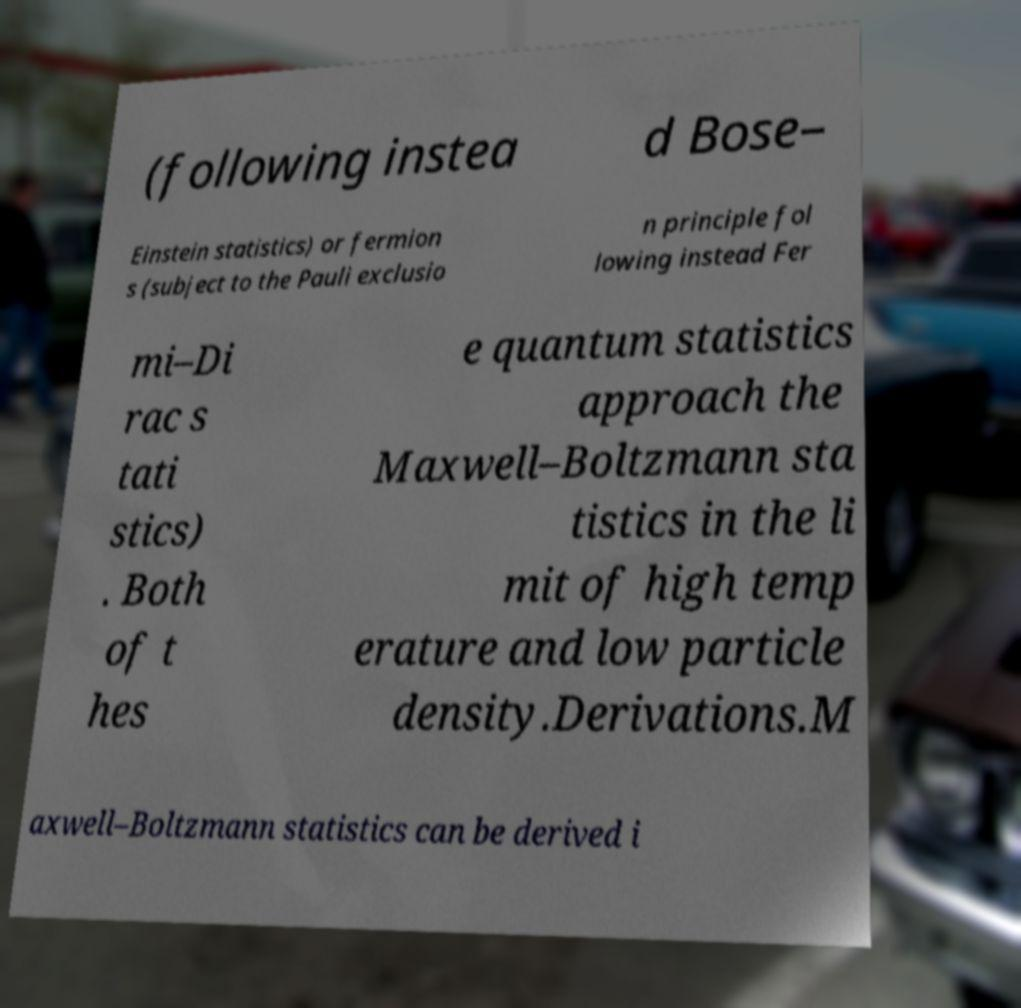I need the written content from this picture converted into text. Can you do that? (following instea d Bose– Einstein statistics) or fermion s (subject to the Pauli exclusio n principle fol lowing instead Fer mi–Di rac s tati stics) . Both of t hes e quantum statistics approach the Maxwell–Boltzmann sta tistics in the li mit of high temp erature and low particle density.Derivations.M axwell–Boltzmann statistics can be derived i 